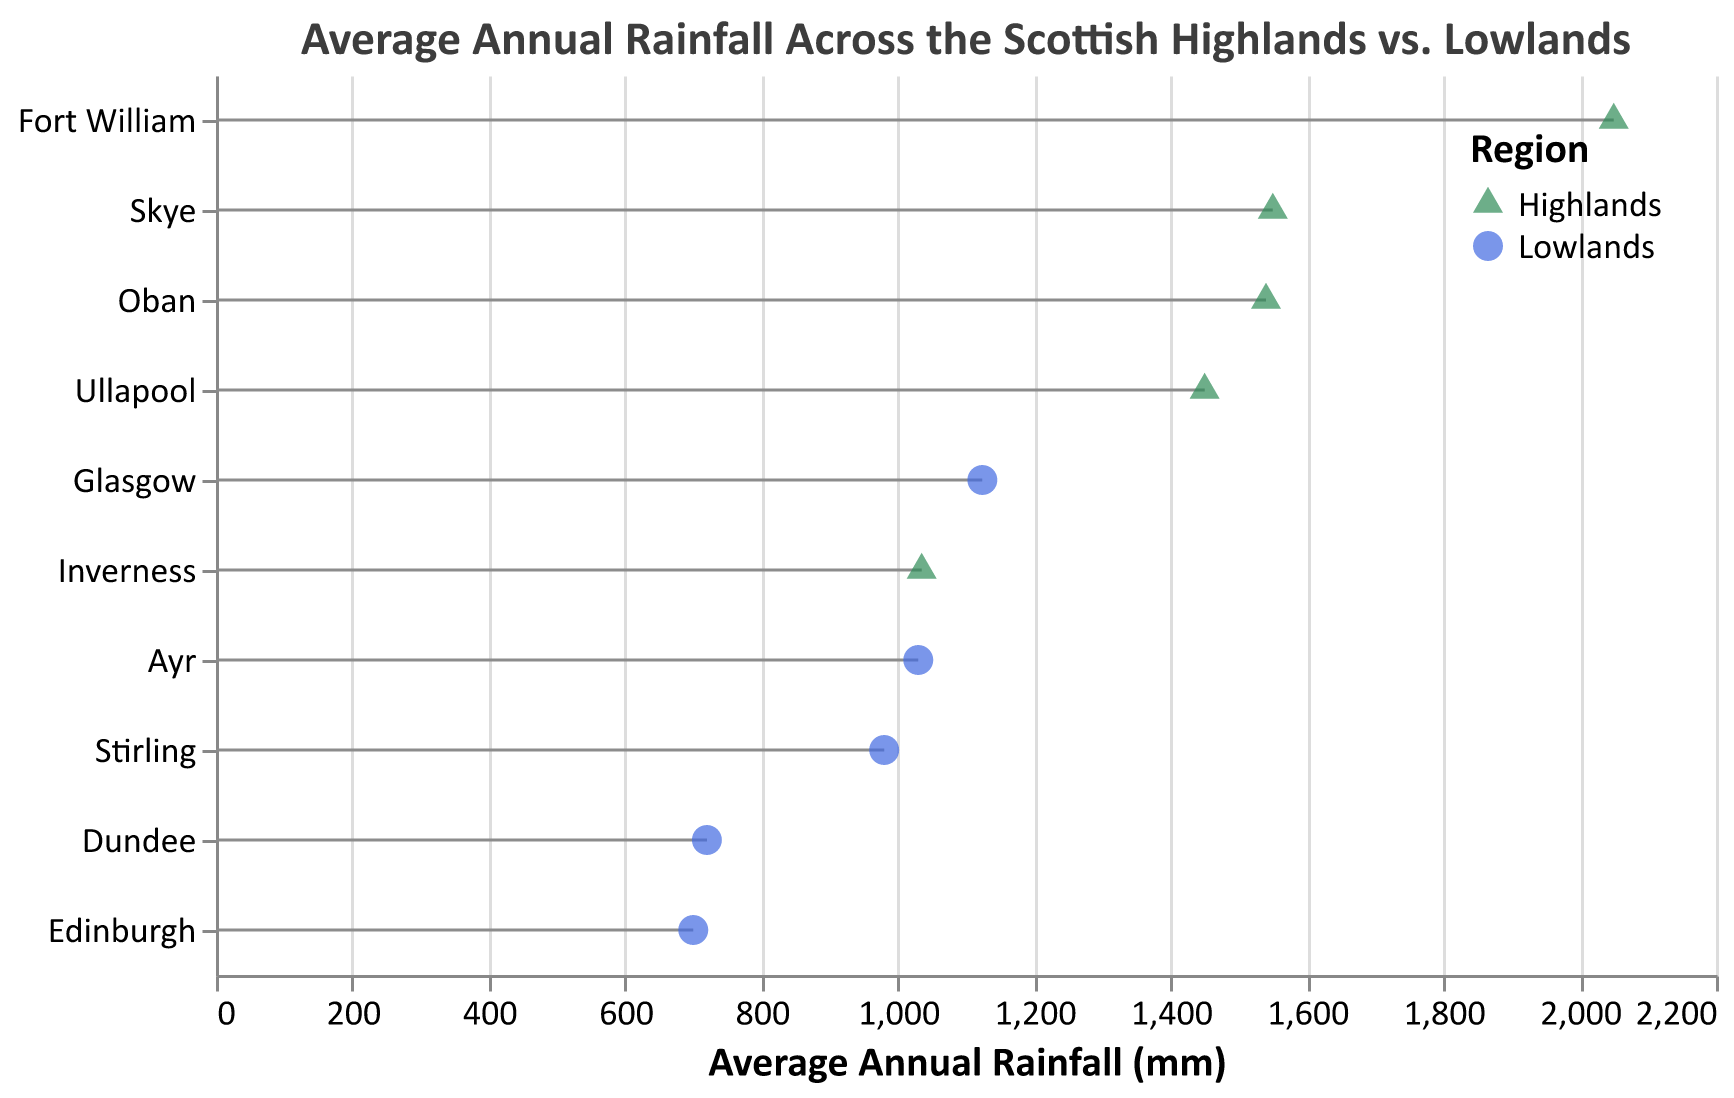What's the title of this plot? The title is usually shown at the top of the figure. In this case, it reads "Average Annual Rainfall Across the Scottish Highlands vs. Lowlands."
Answer: Average Annual Rainfall Across the Scottish Highlands vs. Lowlands How many different locations does the plot show? To count the number of different locations, we observe each unique y-axis label. There are 10 labels (Fort William, Inverness, Oban, Skye, Ullapool, Edinburgh, Glasgow, Dundee, Ayr, Stirling).
Answer: 10 What is the color used to represent the Highlands? Colors representing different regions are indicated in the legend. The Highlands are represented by a greenish color.
Answer: Green Which region receives more rainfall on average, the Scottish Highlands or Lowlands? By looking at the average annual rainfall values for both regions on the x-axis, the locations in the Highlands (with values ranging from 1035 to 2050 mm) generally receive more rainfall than those in the Lowlands (with values ranging from 700 to 1124 mm).
Answer: Highlands Which location has the highest average annual rainfall? We can identify the location with the highest value on the x-axis. Fort William in the Highlands has the highest average annual rainfall (2050 mm).
Answer: Fort William Among the Lowlands, which location receives the most rainfall? By comparing all Lowland locations on the x-axis, Glasgow has the highest rainfall with an average of 1124 mm.
Answer: Glasgow What's the difference in average annual rainfall between Fort William and Edinburgh? Fort William has 2050 mm and Edinburgh has 700 mm. Subtracting these two values gives us a difference of 1350 mm.
Answer: 1350 mm Which location in the Highlands have the least average annual rainfall? By identifying the location in the Highlands with the smallest x-value, Inverness has the least average annual rainfall at 1035 mm.
Answer: Inverness Calculate the average rainfall among the Highland locations. Sum up the rainfall values of Highland locations (2050, 1035, 1540, 1550, 1450) and divide by the number of locations. So, (2050 + 1035 + 1540 + 1550 + 1450) / 5 equals 1525 mm.
Answer: 1525 mm What shape is used to represent the Lowlands? According to the legend, the shape used for the Lowlands is a circle.
Answer: Circle 